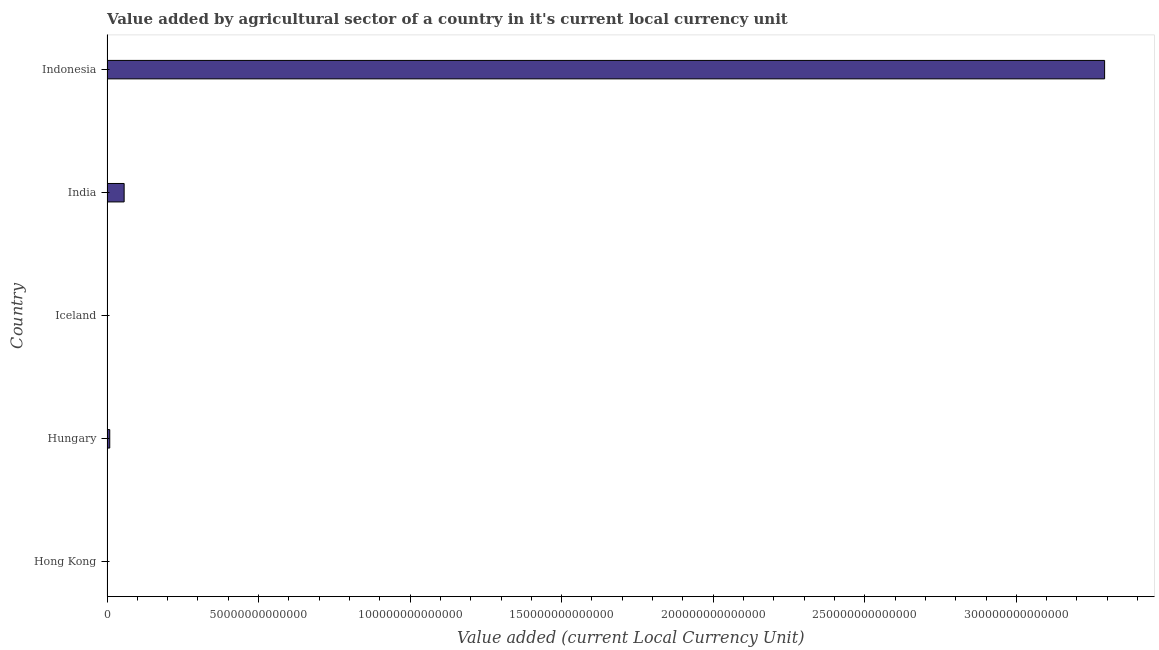Does the graph contain grids?
Your response must be concise. No. What is the title of the graph?
Ensure brevity in your answer.  Value added by agricultural sector of a country in it's current local currency unit. What is the label or title of the X-axis?
Keep it short and to the point. Value added (current Local Currency Unit). What is the label or title of the Y-axis?
Keep it short and to the point. Country. What is the value added by agriculture sector in Iceland?
Your answer should be compact. 5.16e+1. Across all countries, what is the maximum value added by agriculture sector?
Provide a short and direct response. 3.29e+14. Across all countries, what is the minimum value added by agriculture sector?
Give a very brief answer. 9.63e+08. In which country was the value added by agriculture sector minimum?
Keep it short and to the point. Hong Kong. What is the sum of the value added by agriculture sector?
Your answer should be very brief. 3.36e+14. What is the difference between the value added by agriculture sector in Hungary and Indonesia?
Give a very brief answer. -3.28e+14. What is the average value added by agriculture sector per country?
Your response must be concise. 6.71e+13. What is the median value added by agriculture sector?
Give a very brief answer. 9.06e+11. Is the value added by agriculture sector in Iceland less than that in Indonesia?
Make the answer very short. Yes. Is the difference between the value added by agriculture sector in Hong Kong and Hungary greater than the difference between any two countries?
Offer a terse response. No. What is the difference between the highest and the second highest value added by agriculture sector?
Keep it short and to the point. 3.23e+14. What is the difference between the highest and the lowest value added by agriculture sector?
Make the answer very short. 3.29e+14. How many bars are there?
Your answer should be compact. 5. Are all the bars in the graph horizontal?
Provide a succinct answer. Yes. How many countries are there in the graph?
Keep it short and to the point. 5. What is the difference between two consecutive major ticks on the X-axis?
Give a very brief answer. 5.00e+13. What is the Value added (current Local Currency Unit) of Hong Kong?
Provide a short and direct response. 9.63e+08. What is the Value added (current Local Currency Unit) of Hungary?
Offer a terse response. 9.06e+11. What is the Value added (current Local Currency Unit) of Iceland?
Offer a terse response. 5.16e+1. What is the Value added (current Local Currency Unit) in India?
Your answer should be compact. 5.65e+12. What is the Value added (current Local Currency Unit) in Indonesia?
Give a very brief answer. 3.29e+14. What is the difference between the Value added (current Local Currency Unit) in Hong Kong and Hungary?
Provide a short and direct response. -9.05e+11. What is the difference between the Value added (current Local Currency Unit) in Hong Kong and Iceland?
Keep it short and to the point. -5.06e+1. What is the difference between the Value added (current Local Currency Unit) in Hong Kong and India?
Keep it short and to the point. -5.65e+12. What is the difference between the Value added (current Local Currency Unit) in Hong Kong and Indonesia?
Provide a short and direct response. -3.29e+14. What is the difference between the Value added (current Local Currency Unit) in Hungary and Iceland?
Offer a terse response. 8.55e+11. What is the difference between the Value added (current Local Currency Unit) in Hungary and India?
Your answer should be very brief. -4.75e+12. What is the difference between the Value added (current Local Currency Unit) in Hungary and Indonesia?
Offer a very short reply. -3.28e+14. What is the difference between the Value added (current Local Currency Unit) in Iceland and India?
Provide a succinct answer. -5.60e+12. What is the difference between the Value added (current Local Currency Unit) in Iceland and Indonesia?
Your answer should be very brief. -3.29e+14. What is the difference between the Value added (current Local Currency Unit) in India and Indonesia?
Your response must be concise. -3.23e+14. What is the ratio of the Value added (current Local Currency Unit) in Hong Kong to that in Iceland?
Provide a succinct answer. 0.02. What is the ratio of the Value added (current Local Currency Unit) in Hong Kong to that in India?
Make the answer very short. 0. What is the ratio of the Value added (current Local Currency Unit) in Hong Kong to that in Indonesia?
Keep it short and to the point. 0. What is the ratio of the Value added (current Local Currency Unit) in Hungary to that in Iceland?
Your answer should be compact. 17.57. What is the ratio of the Value added (current Local Currency Unit) in Hungary to that in India?
Your answer should be compact. 0.16. What is the ratio of the Value added (current Local Currency Unit) in Hungary to that in Indonesia?
Offer a very short reply. 0. What is the ratio of the Value added (current Local Currency Unit) in Iceland to that in India?
Give a very brief answer. 0.01. What is the ratio of the Value added (current Local Currency Unit) in Iceland to that in Indonesia?
Your response must be concise. 0. What is the ratio of the Value added (current Local Currency Unit) in India to that in Indonesia?
Your response must be concise. 0.02. 